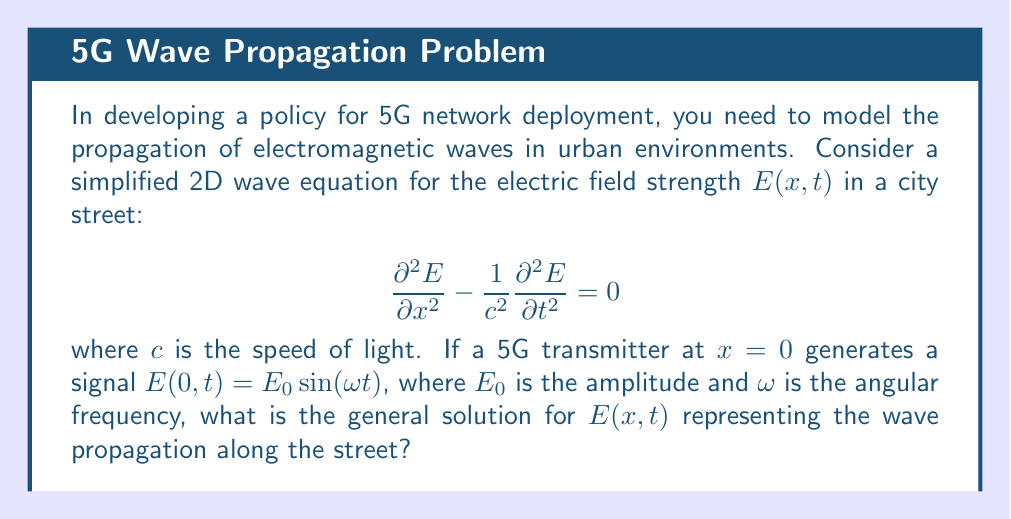What is the answer to this math problem? To solve this problem, we'll follow these steps:

1) The given wave equation is:

   $$\frac{\partial^2 E}{\partial x^2} - \frac{1}{c^2}\frac{\partial^2 E}{\partial t^2} = 0$$

2) We're looking for a solution that satisfies this equation and the boundary condition:

   $E(0,t) = E_0 \sin(\omega t)$

3) The general solution to the wave equation is of the form:

   $$E(x,t) = f(x-ct) + g(x+ct)$$

   where $f$ and $g$ are arbitrary functions.

4) Given the boundary condition, we can deduce that the solution should be a traveling wave moving in the positive x-direction:

   $$E(x,t) = E_0 \sin(\omega(t - \frac{x}{c}))$$

5) To verify this solution, we can substitute it back into the original equation:

   $$\frac{\partial^2 E}{\partial x^2} = -E_0 (\frac{\omega}{c})^2 \sin(\omega(t - \frac{x}{c}))$$
   $$\frac{\partial^2 E}{\partial t^2} = -E_0 \omega^2 \sin(\omega(t - \frac{x}{c}))$$

6) Substituting these into the wave equation:

   $$-E_0 (\frac{\omega}{c})^2 \sin(\omega(t - \frac{x}{c})) + \frac{1}{c^2}E_0 \omega^2 \sin(\omega(t - \frac{x}{c})) = 0$$

   This equality holds, confirming our solution.

7) We can also express this solution in terms of wavenumber $k = \frac{\omega}{c}$:

   $$E(x,t) = E_0 \sin(\omega t - kx)$$

This solution represents a wave traveling in the positive x-direction with amplitude $E_0$, angular frequency $\omega$, and wavenumber $k$.
Answer: $E(x,t) = E_0 \sin(\omega t - kx)$ 